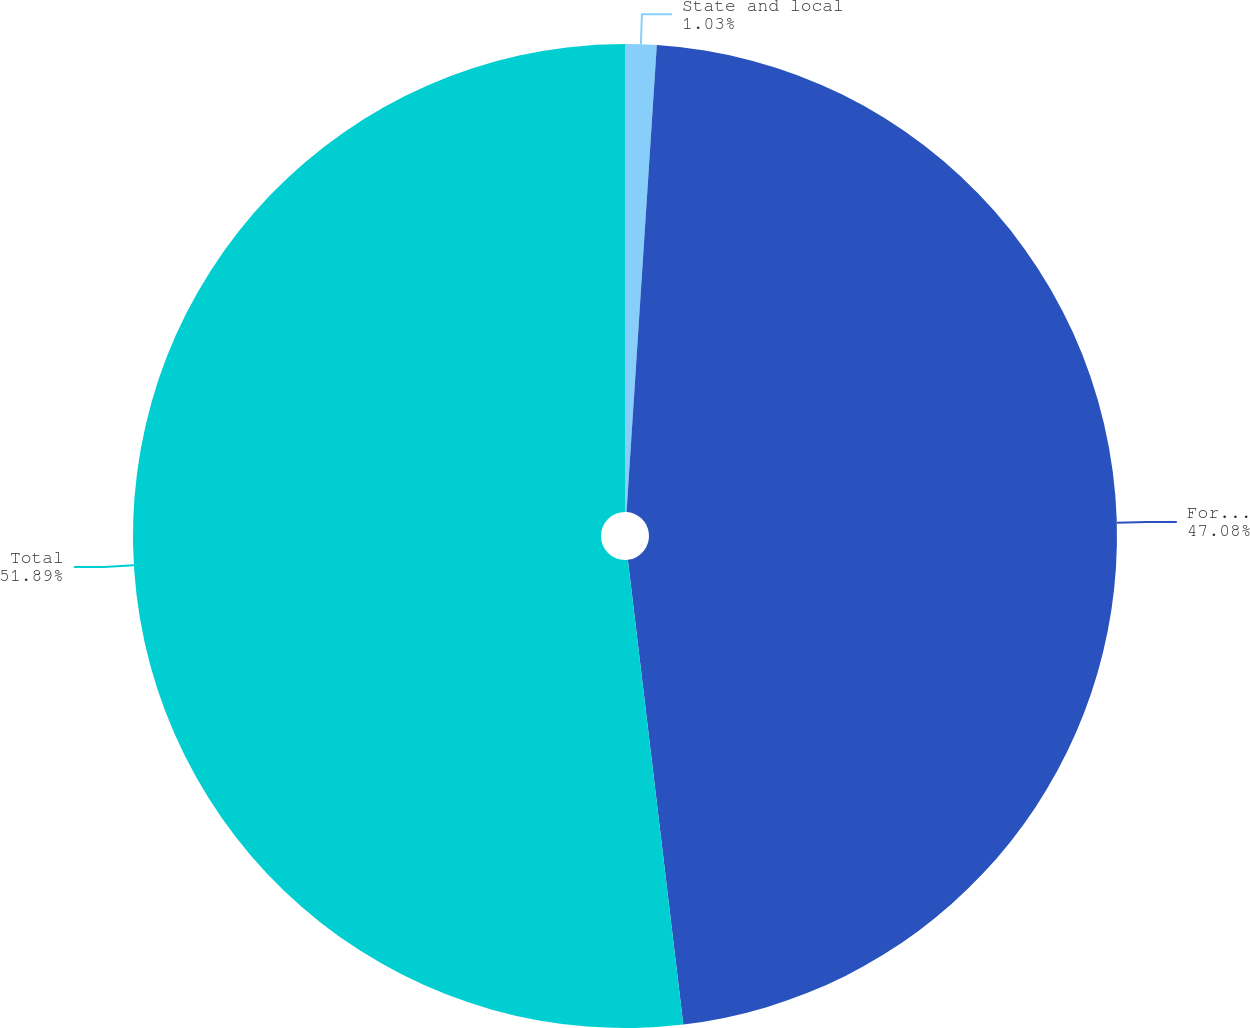Convert chart to OTSL. <chart><loc_0><loc_0><loc_500><loc_500><pie_chart><fcel>State and local<fcel>Foreign<fcel>Total<nl><fcel>1.03%<fcel>47.08%<fcel>51.89%<nl></chart> 